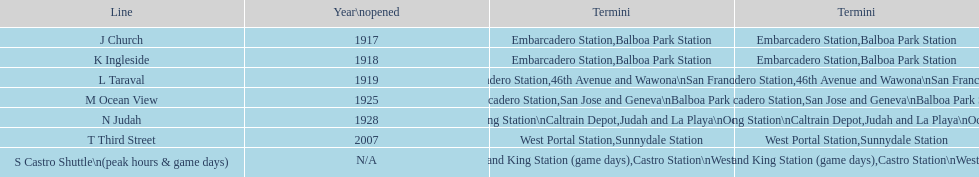On game days, which line do you want to use? S Castro Shuttle. 